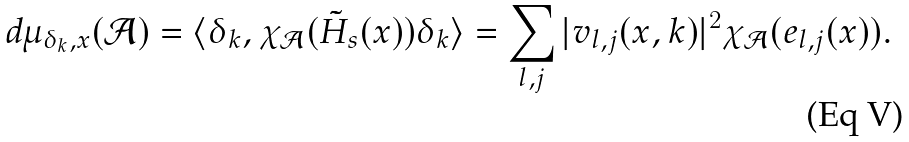Convert formula to latex. <formula><loc_0><loc_0><loc_500><loc_500>d \mu _ { \delta _ { k } , x } ( \mathcal { A } ) = \langle \delta _ { k } , \chi _ { \mathcal { A } } ( \tilde { H } _ { s } ( x ) ) \delta _ { k } \rangle = \sum _ { l , j } | v _ { l , j } ( x , k ) | ^ { 2 } \chi _ { \mathcal { A } } ( e _ { l , j } ( x ) ) .</formula> 